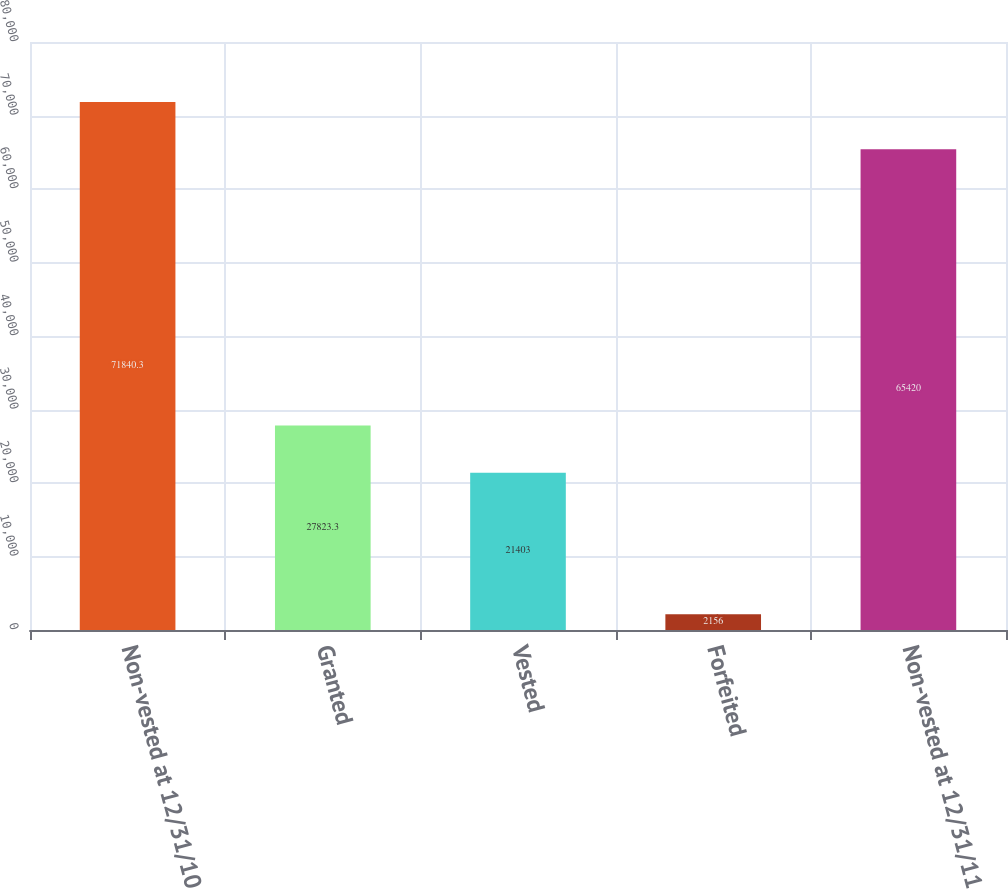Convert chart to OTSL. <chart><loc_0><loc_0><loc_500><loc_500><bar_chart><fcel>Non-vested at 12/31/10<fcel>Granted<fcel>Vested<fcel>Forfeited<fcel>Non-vested at 12/31/11<nl><fcel>71840.3<fcel>27823.3<fcel>21403<fcel>2156<fcel>65420<nl></chart> 